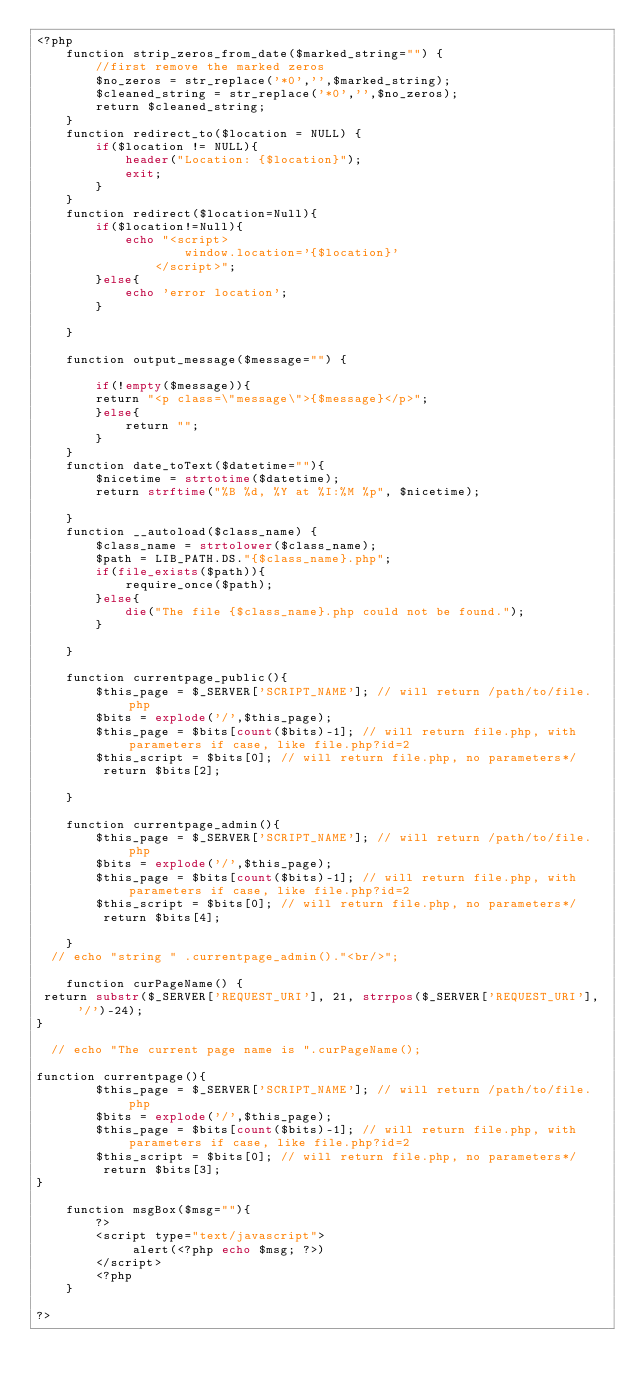<code> <loc_0><loc_0><loc_500><loc_500><_PHP_><?php
	function strip_zeros_from_date($marked_string="") {
		//first remove the marked zeros
		$no_zeros = str_replace('*0','',$marked_string);
		$cleaned_string = str_replace('*0','',$no_zeros);
		return $cleaned_string;
	}
	function redirect_to($location = NULL) {
		if($location != NULL){
			header("Location: {$location}");
			exit;
		}
	}
	function redirect($location=Null){
		if($location!=Null){
			echo "<script>
					window.location='{$location}'
				</script>";	
		}else{
			echo 'error location';
		}
		 
	}
	
	function output_message($message="") {
	
		if(!empty($message)){
		return "<p class=\"message\">{$message}</p>";
		}else{
			return "";
		}
	}
	function date_toText($datetime=""){
		$nicetime = strtotime($datetime);
		return strftime("%B %d, %Y at %I:%M %p", $nicetime);	
					
	}
	function __autoload($class_name) {
		$class_name = strtolower($class_name);
		$path = LIB_PATH.DS."{$class_name}.php";
		if(file_exists($path)){
			require_once($path);
		}else{
			die("The file {$class_name}.php could not be found.");
		}
					
	}

	function currentpage_public(){
		$this_page = $_SERVER['SCRIPT_NAME']; // will return /path/to/file.php
	    $bits = explode('/',$this_page);
	    $this_page = $bits[count($bits)-1]; // will return file.php, with parameters if case, like file.php?id=2
	    $this_script = $bits[0]; // will return file.php, no parameters*/
		 return $bits[2];
	  
	}

	function currentpage_admin(){
		$this_page = $_SERVER['SCRIPT_NAME']; // will return /path/to/file.php
	    $bits = explode('/',$this_page);
	    $this_page = $bits[count($bits)-1]; // will return file.php, with parameters if case, like file.php?id=2
	    $this_script = $bits[0]; // will return file.php, no parameters*/
		 return $bits[4];
	  
	}
  // echo "string " .currentpage_admin()."<br/>";

	function curPageName() {
 return substr($_SERVER['REQUEST_URI'], 21, strrpos($_SERVER['REQUEST_URI'], '/')-24);
}

  // echo "The current page name is ".curPageName();

function currentpage(){
		$this_page = $_SERVER['SCRIPT_NAME']; // will return /path/to/file.php
	    $bits = explode('/',$this_page);
	    $this_page = $bits[count($bits)-1]; // will return file.php, with parameters if case, like file.php?id=2
	    $this_script = $bits[0]; // will return file.php, no parameters*/
		 return $bits[3];
}
	 
	function msgBox($msg=""){
		?>
		<script type="text/javascript">
			 alert(<?php echo $msg; ?>)
		</script>
		<?php
	}
		
?></code> 